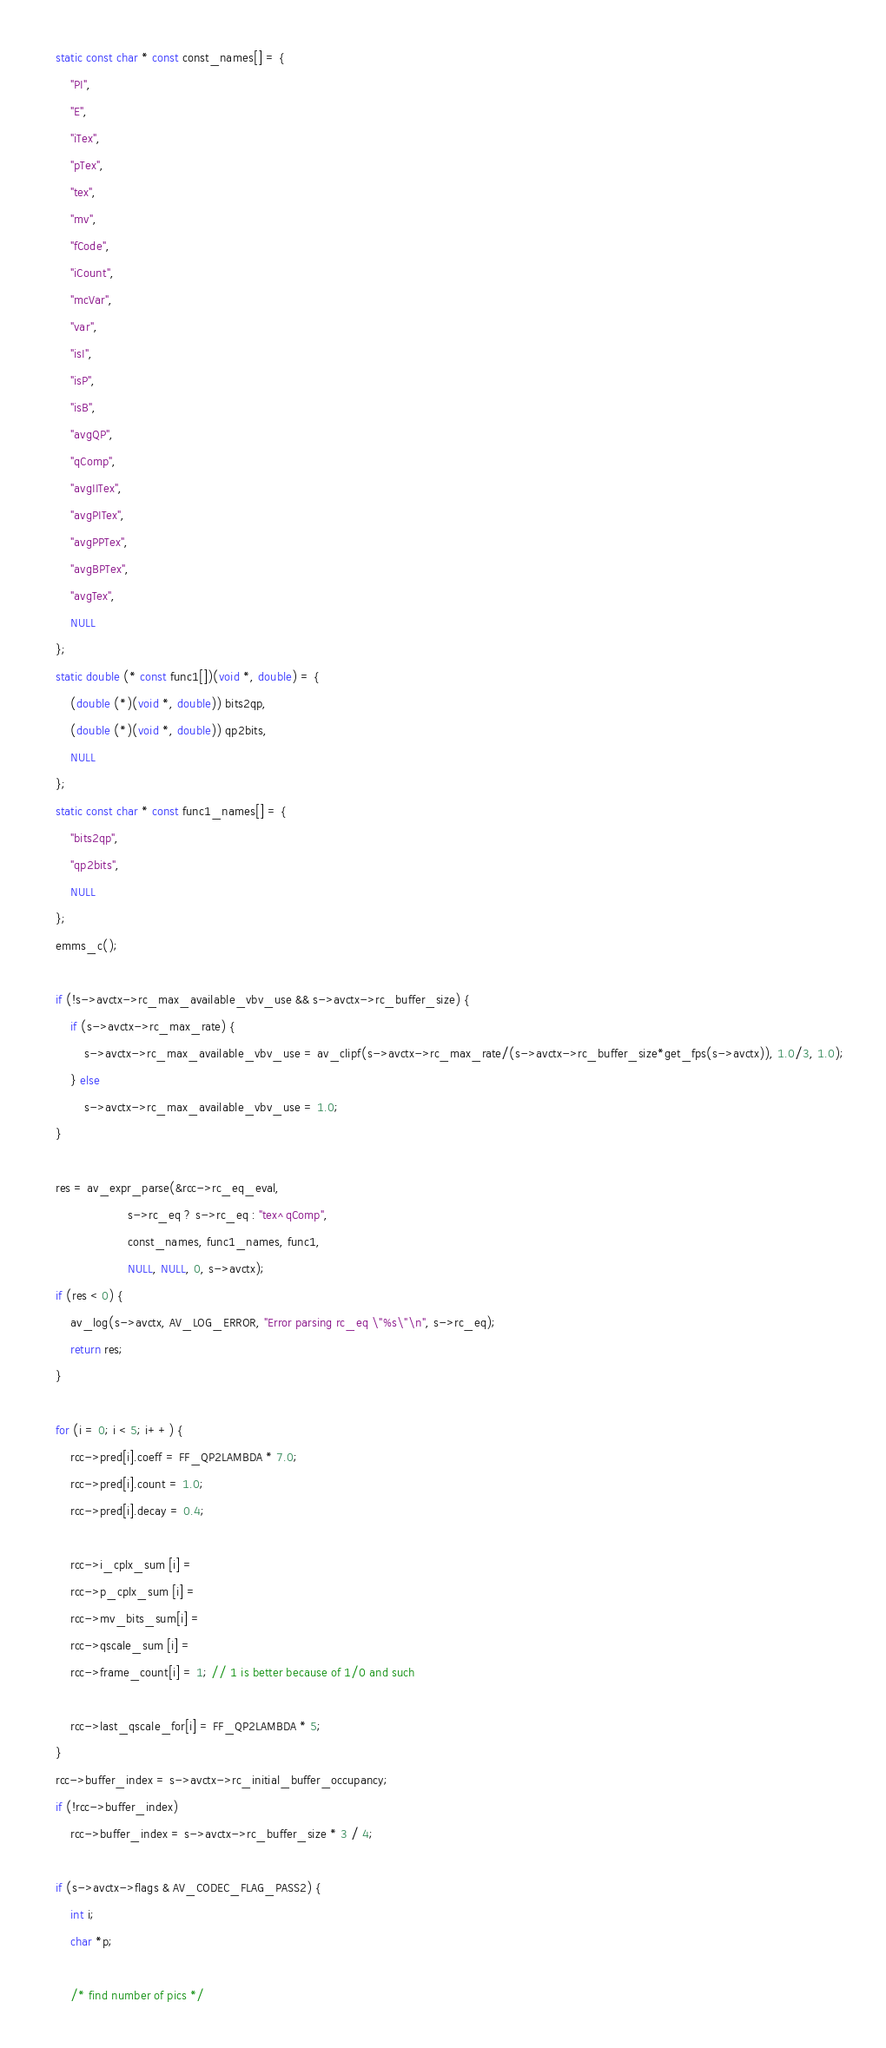<code> <loc_0><loc_0><loc_500><loc_500><_C++_>    static const char * const const_names[] = {
        "PI",
        "E",
        "iTex",
        "pTex",
        "tex",
        "mv",
        "fCode",
        "iCount",
        "mcVar",
        "var",
        "isI",
        "isP",
        "isB",
        "avgQP",
        "qComp",
        "avgIITex",
        "avgPITex",
        "avgPPTex",
        "avgBPTex",
        "avgTex",
        NULL
    };
    static double (* const func1[])(void *, double) = {
        (double (*)(void *, double)) bits2qp,
        (double (*)(void *, double)) qp2bits,
        NULL
    };
    static const char * const func1_names[] = {
        "bits2qp",
        "qp2bits",
        NULL
    };
    emms_c();

    if (!s->avctx->rc_max_available_vbv_use && s->avctx->rc_buffer_size) {
        if (s->avctx->rc_max_rate) {
            s->avctx->rc_max_available_vbv_use = av_clipf(s->avctx->rc_max_rate/(s->avctx->rc_buffer_size*get_fps(s->avctx)), 1.0/3, 1.0);
        } else
            s->avctx->rc_max_available_vbv_use = 1.0;
    }

    res = av_expr_parse(&rcc->rc_eq_eval,
                        s->rc_eq ? s->rc_eq : "tex^qComp",
                        const_names, func1_names, func1,
                        NULL, NULL, 0, s->avctx);
    if (res < 0) {
        av_log(s->avctx, AV_LOG_ERROR, "Error parsing rc_eq \"%s\"\n", s->rc_eq);
        return res;
    }

    for (i = 0; i < 5; i++) {
        rcc->pred[i].coeff = FF_QP2LAMBDA * 7.0;
        rcc->pred[i].count = 1.0;
        rcc->pred[i].decay = 0.4;

        rcc->i_cplx_sum [i] =
        rcc->p_cplx_sum [i] =
        rcc->mv_bits_sum[i] =
        rcc->qscale_sum [i] =
        rcc->frame_count[i] = 1; // 1 is better because of 1/0 and such

        rcc->last_qscale_for[i] = FF_QP2LAMBDA * 5;
    }
    rcc->buffer_index = s->avctx->rc_initial_buffer_occupancy;
    if (!rcc->buffer_index)
        rcc->buffer_index = s->avctx->rc_buffer_size * 3 / 4;

    if (s->avctx->flags & AV_CODEC_FLAG_PASS2) {
        int i;
        char *p;

        /* find number of pics */</code> 